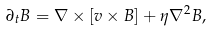Convert formula to latex. <formula><loc_0><loc_0><loc_500><loc_500>\partial _ { t } { B } = \nabla \times [ { v \times B } ] + \eta \nabla ^ { 2 } { B } ,</formula> 